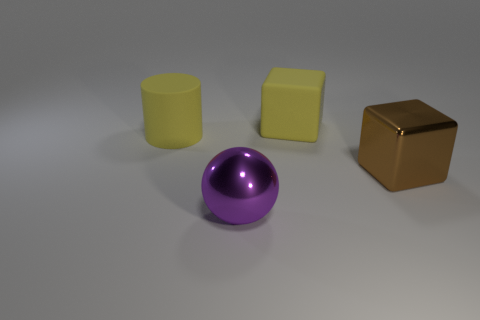Add 2 brown blocks. How many objects exist? 6 Subtract all yellow blocks. How many blocks are left? 1 Subtract all cylinders. How many objects are left? 3 Subtract all green cylinders. Subtract all yellow balls. How many cylinders are left? 1 Subtract all big cyan shiny cylinders. Subtract all brown things. How many objects are left? 3 Add 1 brown metal objects. How many brown metal objects are left? 2 Add 4 big purple shiny spheres. How many big purple shiny spheres exist? 5 Subtract 0 green blocks. How many objects are left? 4 Subtract 1 cylinders. How many cylinders are left? 0 